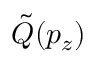<formula> <loc_0><loc_0><loc_500><loc_500>\tilde { Q } ( p _ { z } )</formula> 